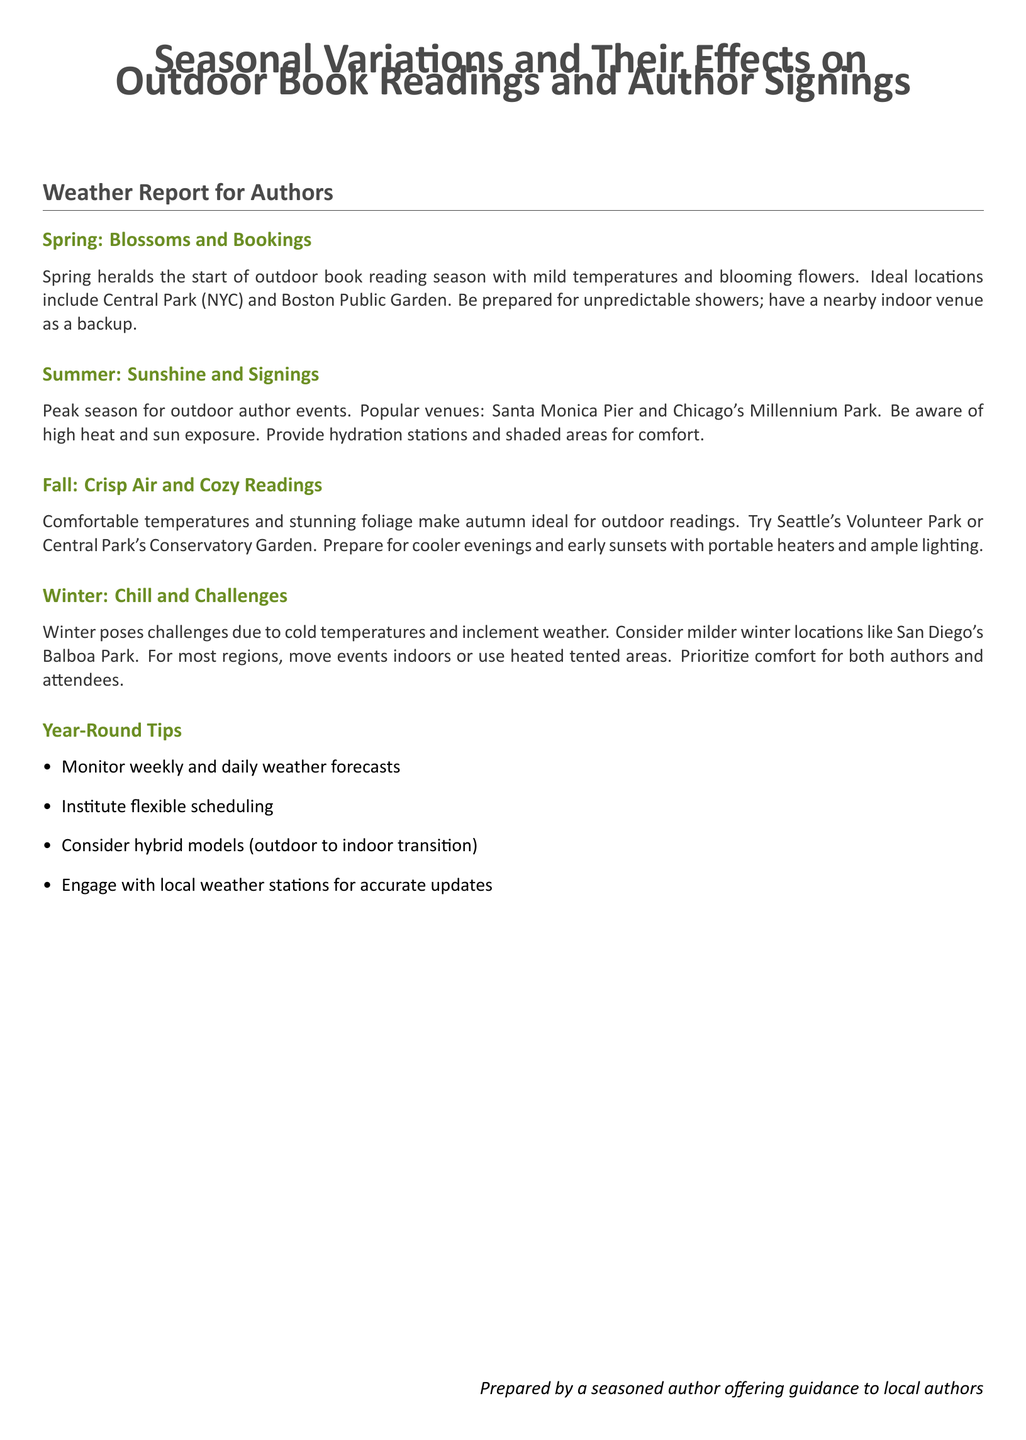What season marks the start of outdoor book readings? The document states that spring heralds the start of outdoor book reading season.
Answer: Spring Which two locations are recommended for spring outdoor readings? The document mentions Central Park (NYC) and Boston Public Garden as ideal locations for spring readings.
Answer: Central Park (NYC) and Boston Public Garden What weather-related preparation is suggested for spring events? The report advises having a nearby indoor venue as a backup due to unpredictable showers in spring.
Answer: Indoor venue During which season is it advisable to provide hydration stations? The document highlights that summer is the peak season for outdoor author events and advises providing hydration stations.
Answer: Summer What type of heating is recommended for fall events? The report suggests using portable heaters to prepare for cooler evenings during fall readings.
Answer: Portable heaters What is the primary challenge of hosting events in winter? The document points out that cold temperatures and inclement weather pose challenges for winter events.
Answer: Cold temperatures Name one location suggested for winter events. The document mentions San Diego's Balboa Park as a milder winter location.
Answer: San Diego's Balboa Park What is one year-round tip provided in the document? One year-round tip is to monitor weekly and daily weather forecasts for outdoor events.
Answer: Monitor weekly and daily weather forecasts What does hybrid model suggest regarding outdoor events? The document implies that a hybrid model considers transitioning events from outdoor to indoor settings due to weather.
Answer: Hybrid model 